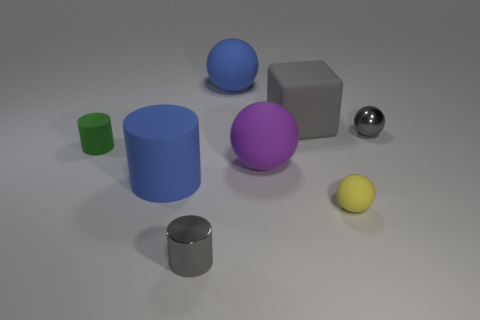Subtract all green rubber cylinders. How many cylinders are left? 2 Subtract all cylinders. How many objects are left? 5 Add 8 gray matte objects. How many gray matte objects exist? 9 Add 1 tiny yellow objects. How many objects exist? 9 Subtract all gray spheres. How many spheres are left? 3 Subtract 0 purple cylinders. How many objects are left? 8 Subtract 2 cylinders. How many cylinders are left? 1 Subtract all cyan spheres. Subtract all purple cylinders. How many spheres are left? 4 Subtract all purple cylinders. How many purple balls are left? 1 Subtract all gray cylinders. Subtract all gray metallic balls. How many objects are left? 6 